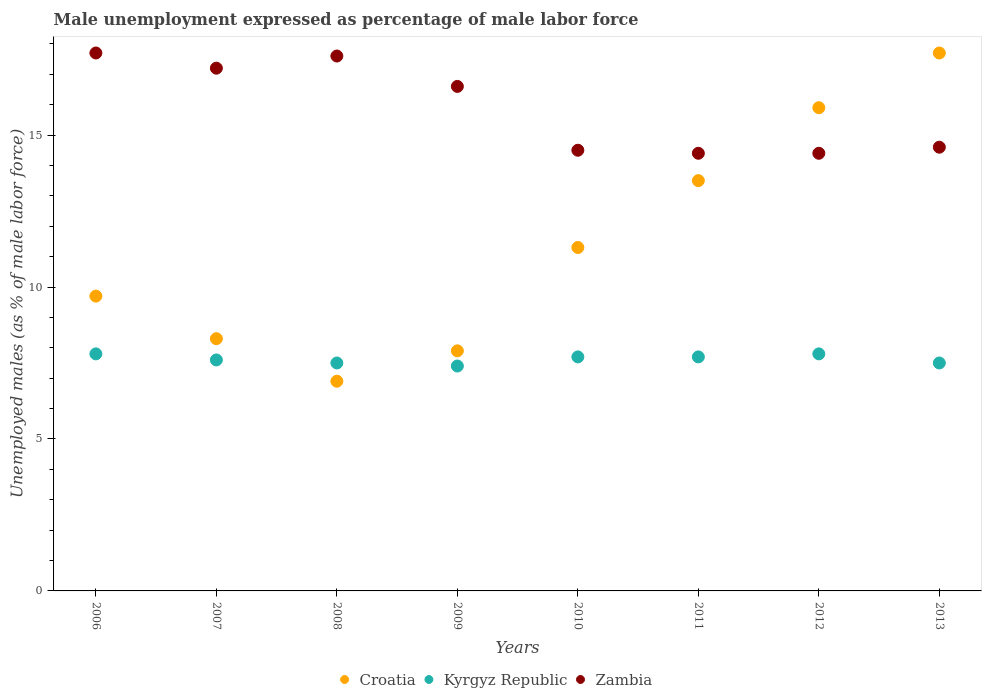Is the number of dotlines equal to the number of legend labels?
Your response must be concise. Yes. What is the unemployment in males in in Kyrgyz Republic in 2011?
Ensure brevity in your answer.  7.7. Across all years, what is the maximum unemployment in males in in Zambia?
Provide a short and direct response. 17.7. Across all years, what is the minimum unemployment in males in in Kyrgyz Republic?
Keep it short and to the point. 7.4. In which year was the unemployment in males in in Kyrgyz Republic minimum?
Offer a terse response. 2009. What is the difference between the unemployment in males in in Croatia in 2006 and that in 2013?
Give a very brief answer. -8. What is the difference between the unemployment in males in in Kyrgyz Republic in 2006 and the unemployment in males in in Zambia in 2010?
Provide a succinct answer. -6.7. What is the average unemployment in males in in Kyrgyz Republic per year?
Make the answer very short. 7.62. In the year 2008, what is the difference between the unemployment in males in in Kyrgyz Republic and unemployment in males in in Croatia?
Provide a short and direct response. 0.6. In how many years, is the unemployment in males in in Kyrgyz Republic greater than 17 %?
Your response must be concise. 0. What is the ratio of the unemployment in males in in Kyrgyz Republic in 2007 to that in 2010?
Provide a short and direct response. 0.99. What is the difference between the highest and the lowest unemployment in males in in Zambia?
Keep it short and to the point. 3.3. In how many years, is the unemployment in males in in Zambia greater than the average unemployment in males in in Zambia taken over all years?
Your response must be concise. 4. Is the unemployment in males in in Croatia strictly greater than the unemployment in males in in Kyrgyz Republic over the years?
Give a very brief answer. No. Is the unemployment in males in in Zambia strictly less than the unemployment in males in in Kyrgyz Republic over the years?
Keep it short and to the point. No. How many years are there in the graph?
Your response must be concise. 8. What is the difference between two consecutive major ticks on the Y-axis?
Make the answer very short. 5. Are the values on the major ticks of Y-axis written in scientific E-notation?
Give a very brief answer. No. Does the graph contain any zero values?
Ensure brevity in your answer.  No. Does the graph contain grids?
Make the answer very short. No. How are the legend labels stacked?
Your answer should be very brief. Horizontal. What is the title of the graph?
Provide a succinct answer. Male unemployment expressed as percentage of male labor force. Does "Dominican Republic" appear as one of the legend labels in the graph?
Your answer should be compact. No. What is the label or title of the Y-axis?
Offer a terse response. Unemployed males (as % of male labor force). What is the Unemployed males (as % of male labor force) in Croatia in 2006?
Make the answer very short. 9.7. What is the Unemployed males (as % of male labor force) of Kyrgyz Republic in 2006?
Your answer should be very brief. 7.8. What is the Unemployed males (as % of male labor force) of Zambia in 2006?
Provide a short and direct response. 17.7. What is the Unemployed males (as % of male labor force) in Croatia in 2007?
Offer a very short reply. 8.3. What is the Unemployed males (as % of male labor force) in Kyrgyz Republic in 2007?
Keep it short and to the point. 7.6. What is the Unemployed males (as % of male labor force) of Zambia in 2007?
Your answer should be very brief. 17.2. What is the Unemployed males (as % of male labor force) of Croatia in 2008?
Offer a very short reply. 6.9. What is the Unemployed males (as % of male labor force) in Kyrgyz Republic in 2008?
Your response must be concise. 7.5. What is the Unemployed males (as % of male labor force) in Zambia in 2008?
Make the answer very short. 17.6. What is the Unemployed males (as % of male labor force) in Croatia in 2009?
Offer a terse response. 7.9. What is the Unemployed males (as % of male labor force) of Kyrgyz Republic in 2009?
Give a very brief answer. 7.4. What is the Unemployed males (as % of male labor force) in Zambia in 2009?
Make the answer very short. 16.6. What is the Unemployed males (as % of male labor force) in Croatia in 2010?
Ensure brevity in your answer.  11.3. What is the Unemployed males (as % of male labor force) of Kyrgyz Republic in 2010?
Provide a succinct answer. 7.7. What is the Unemployed males (as % of male labor force) of Kyrgyz Republic in 2011?
Provide a short and direct response. 7.7. What is the Unemployed males (as % of male labor force) in Zambia in 2011?
Your answer should be very brief. 14.4. What is the Unemployed males (as % of male labor force) in Croatia in 2012?
Offer a terse response. 15.9. What is the Unemployed males (as % of male labor force) of Kyrgyz Republic in 2012?
Offer a terse response. 7.8. What is the Unemployed males (as % of male labor force) of Zambia in 2012?
Make the answer very short. 14.4. What is the Unemployed males (as % of male labor force) of Croatia in 2013?
Provide a succinct answer. 17.7. What is the Unemployed males (as % of male labor force) in Zambia in 2013?
Your answer should be compact. 14.6. Across all years, what is the maximum Unemployed males (as % of male labor force) in Croatia?
Give a very brief answer. 17.7. Across all years, what is the maximum Unemployed males (as % of male labor force) of Kyrgyz Republic?
Make the answer very short. 7.8. Across all years, what is the maximum Unemployed males (as % of male labor force) of Zambia?
Offer a terse response. 17.7. Across all years, what is the minimum Unemployed males (as % of male labor force) in Croatia?
Keep it short and to the point. 6.9. Across all years, what is the minimum Unemployed males (as % of male labor force) in Kyrgyz Republic?
Provide a short and direct response. 7.4. Across all years, what is the minimum Unemployed males (as % of male labor force) in Zambia?
Ensure brevity in your answer.  14.4. What is the total Unemployed males (as % of male labor force) in Croatia in the graph?
Keep it short and to the point. 91.2. What is the total Unemployed males (as % of male labor force) of Kyrgyz Republic in the graph?
Offer a terse response. 61. What is the total Unemployed males (as % of male labor force) of Zambia in the graph?
Provide a succinct answer. 127. What is the difference between the Unemployed males (as % of male labor force) of Croatia in 2006 and that in 2007?
Make the answer very short. 1.4. What is the difference between the Unemployed males (as % of male labor force) of Croatia in 2006 and that in 2008?
Provide a succinct answer. 2.8. What is the difference between the Unemployed males (as % of male labor force) of Zambia in 2006 and that in 2008?
Ensure brevity in your answer.  0.1. What is the difference between the Unemployed males (as % of male labor force) in Croatia in 2006 and that in 2009?
Your answer should be compact. 1.8. What is the difference between the Unemployed males (as % of male labor force) in Croatia in 2006 and that in 2010?
Give a very brief answer. -1.6. What is the difference between the Unemployed males (as % of male labor force) of Zambia in 2006 and that in 2010?
Ensure brevity in your answer.  3.2. What is the difference between the Unemployed males (as % of male labor force) in Croatia in 2006 and that in 2011?
Make the answer very short. -3.8. What is the difference between the Unemployed males (as % of male labor force) of Zambia in 2006 and that in 2011?
Give a very brief answer. 3.3. What is the difference between the Unemployed males (as % of male labor force) in Kyrgyz Republic in 2006 and that in 2013?
Your answer should be very brief. 0.3. What is the difference between the Unemployed males (as % of male labor force) in Zambia in 2006 and that in 2013?
Ensure brevity in your answer.  3.1. What is the difference between the Unemployed males (as % of male labor force) of Kyrgyz Republic in 2007 and that in 2008?
Provide a succinct answer. 0.1. What is the difference between the Unemployed males (as % of male labor force) in Zambia in 2007 and that in 2008?
Give a very brief answer. -0.4. What is the difference between the Unemployed males (as % of male labor force) in Zambia in 2007 and that in 2010?
Your response must be concise. 2.7. What is the difference between the Unemployed males (as % of male labor force) of Croatia in 2007 and that in 2011?
Give a very brief answer. -5.2. What is the difference between the Unemployed males (as % of male labor force) in Kyrgyz Republic in 2007 and that in 2011?
Your response must be concise. -0.1. What is the difference between the Unemployed males (as % of male labor force) in Zambia in 2007 and that in 2011?
Provide a succinct answer. 2.8. What is the difference between the Unemployed males (as % of male labor force) of Kyrgyz Republic in 2007 and that in 2013?
Make the answer very short. 0.1. What is the difference between the Unemployed males (as % of male labor force) of Zambia in 2007 and that in 2013?
Provide a short and direct response. 2.6. What is the difference between the Unemployed males (as % of male labor force) in Kyrgyz Republic in 2008 and that in 2009?
Provide a succinct answer. 0.1. What is the difference between the Unemployed males (as % of male labor force) in Zambia in 2008 and that in 2009?
Your answer should be very brief. 1. What is the difference between the Unemployed males (as % of male labor force) in Kyrgyz Republic in 2008 and that in 2010?
Keep it short and to the point. -0.2. What is the difference between the Unemployed males (as % of male labor force) in Zambia in 2008 and that in 2010?
Ensure brevity in your answer.  3.1. What is the difference between the Unemployed males (as % of male labor force) of Kyrgyz Republic in 2008 and that in 2011?
Provide a short and direct response. -0.2. What is the difference between the Unemployed males (as % of male labor force) of Croatia in 2008 and that in 2012?
Your answer should be very brief. -9. What is the difference between the Unemployed males (as % of male labor force) of Croatia in 2008 and that in 2013?
Offer a very short reply. -10.8. What is the difference between the Unemployed males (as % of male labor force) in Croatia in 2009 and that in 2010?
Your answer should be very brief. -3.4. What is the difference between the Unemployed males (as % of male labor force) in Kyrgyz Republic in 2009 and that in 2011?
Provide a short and direct response. -0.3. What is the difference between the Unemployed males (as % of male labor force) in Croatia in 2009 and that in 2012?
Your answer should be very brief. -8. What is the difference between the Unemployed males (as % of male labor force) of Kyrgyz Republic in 2009 and that in 2012?
Ensure brevity in your answer.  -0.4. What is the difference between the Unemployed males (as % of male labor force) of Croatia in 2009 and that in 2013?
Offer a very short reply. -9.8. What is the difference between the Unemployed males (as % of male labor force) of Zambia in 2010 and that in 2011?
Ensure brevity in your answer.  0.1. What is the difference between the Unemployed males (as % of male labor force) of Kyrgyz Republic in 2010 and that in 2012?
Ensure brevity in your answer.  -0.1. What is the difference between the Unemployed males (as % of male labor force) in Zambia in 2010 and that in 2012?
Your answer should be compact. 0.1. What is the difference between the Unemployed males (as % of male labor force) in Zambia in 2010 and that in 2013?
Give a very brief answer. -0.1. What is the difference between the Unemployed males (as % of male labor force) of Croatia in 2011 and that in 2012?
Your response must be concise. -2.4. What is the difference between the Unemployed males (as % of male labor force) of Croatia in 2012 and that in 2013?
Make the answer very short. -1.8. What is the difference between the Unemployed males (as % of male labor force) of Zambia in 2012 and that in 2013?
Your response must be concise. -0.2. What is the difference between the Unemployed males (as % of male labor force) in Croatia in 2006 and the Unemployed males (as % of male labor force) in Zambia in 2008?
Offer a very short reply. -7.9. What is the difference between the Unemployed males (as % of male labor force) of Kyrgyz Republic in 2006 and the Unemployed males (as % of male labor force) of Zambia in 2008?
Make the answer very short. -9.8. What is the difference between the Unemployed males (as % of male labor force) in Croatia in 2006 and the Unemployed males (as % of male labor force) in Kyrgyz Republic in 2010?
Give a very brief answer. 2. What is the difference between the Unemployed males (as % of male labor force) of Kyrgyz Republic in 2006 and the Unemployed males (as % of male labor force) of Zambia in 2010?
Your response must be concise. -6.7. What is the difference between the Unemployed males (as % of male labor force) in Croatia in 2006 and the Unemployed males (as % of male labor force) in Kyrgyz Republic in 2011?
Give a very brief answer. 2. What is the difference between the Unemployed males (as % of male labor force) in Kyrgyz Republic in 2006 and the Unemployed males (as % of male labor force) in Zambia in 2011?
Offer a terse response. -6.6. What is the difference between the Unemployed males (as % of male labor force) in Kyrgyz Republic in 2006 and the Unemployed males (as % of male labor force) in Zambia in 2012?
Provide a short and direct response. -6.6. What is the difference between the Unemployed males (as % of male labor force) of Croatia in 2006 and the Unemployed males (as % of male labor force) of Kyrgyz Republic in 2013?
Your answer should be very brief. 2.2. What is the difference between the Unemployed males (as % of male labor force) of Croatia in 2006 and the Unemployed males (as % of male labor force) of Zambia in 2013?
Keep it short and to the point. -4.9. What is the difference between the Unemployed males (as % of male labor force) in Kyrgyz Republic in 2006 and the Unemployed males (as % of male labor force) in Zambia in 2013?
Ensure brevity in your answer.  -6.8. What is the difference between the Unemployed males (as % of male labor force) of Croatia in 2007 and the Unemployed males (as % of male labor force) of Zambia in 2008?
Ensure brevity in your answer.  -9.3. What is the difference between the Unemployed males (as % of male labor force) in Kyrgyz Republic in 2007 and the Unemployed males (as % of male labor force) in Zambia in 2008?
Make the answer very short. -10. What is the difference between the Unemployed males (as % of male labor force) in Kyrgyz Republic in 2007 and the Unemployed males (as % of male labor force) in Zambia in 2009?
Make the answer very short. -9. What is the difference between the Unemployed males (as % of male labor force) in Kyrgyz Republic in 2007 and the Unemployed males (as % of male labor force) in Zambia in 2011?
Give a very brief answer. -6.8. What is the difference between the Unemployed males (as % of male labor force) of Croatia in 2007 and the Unemployed males (as % of male labor force) of Kyrgyz Republic in 2012?
Your answer should be compact. 0.5. What is the difference between the Unemployed males (as % of male labor force) of Kyrgyz Republic in 2007 and the Unemployed males (as % of male labor force) of Zambia in 2012?
Provide a succinct answer. -6.8. What is the difference between the Unemployed males (as % of male labor force) of Croatia in 2007 and the Unemployed males (as % of male labor force) of Zambia in 2013?
Your answer should be very brief. -6.3. What is the difference between the Unemployed males (as % of male labor force) in Kyrgyz Republic in 2007 and the Unemployed males (as % of male labor force) in Zambia in 2013?
Offer a terse response. -7. What is the difference between the Unemployed males (as % of male labor force) in Croatia in 2008 and the Unemployed males (as % of male labor force) in Kyrgyz Republic in 2009?
Your answer should be compact. -0.5. What is the difference between the Unemployed males (as % of male labor force) in Kyrgyz Republic in 2008 and the Unemployed males (as % of male labor force) in Zambia in 2009?
Your response must be concise. -9.1. What is the difference between the Unemployed males (as % of male labor force) in Croatia in 2008 and the Unemployed males (as % of male labor force) in Kyrgyz Republic in 2010?
Your answer should be compact. -0.8. What is the difference between the Unemployed males (as % of male labor force) of Croatia in 2008 and the Unemployed males (as % of male labor force) of Kyrgyz Republic in 2011?
Ensure brevity in your answer.  -0.8. What is the difference between the Unemployed males (as % of male labor force) in Croatia in 2008 and the Unemployed males (as % of male labor force) in Zambia in 2011?
Your answer should be very brief. -7.5. What is the difference between the Unemployed males (as % of male labor force) of Kyrgyz Republic in 2008 and the Unemployed males (as % of male labor force) of Zambia in 2011?
Your response must be concise. -6.9. What is the difference between the Unemployed males (as % of male labor force) in Kyrgyz Republic in 2008 and the Unemployed males (as % of male labor force) in Zambia in 2012?
Your answer should be very brief. -6.9. What is the difference between the Unemployed males (as % of male labor force) in Kyrgyz Republic in 2008 and the Unemployed males (as % of male labor force) in Zambia in 2013?
Keep it short and to the point. -7.1. What is the difference between the Unemployed males (as % of male labor force) in Croatia in 2009 and the Unemployed males (as % of male labor force) in Zambia in 2012?
Provide a short and direct response. -6.5. What is the difference between the Unemployed males (as % of male labor force) in Kyrgyz Republic in 2009 and the Unemployed males (as % of male labor force) in Zambia in 2012?
Make the answer very short. -7. What is the difference between the Unemployed males (as % of male labor force) of Kyrgyz Republic in 2009 and the Unemployed males (as % of male labor force) of Zambia in 2013?
Offer a terse response. -7.2. What is the difference between the Unemployed males (as % of male labor force) of Croatia in 2010 and the Unemployed males (as % of male labor force) of Kyrgyz Republic in 2011?
Offer a terse response. 3.6. What is the difference between the Unemployed males (as % of male labor force) of Croatia in 2010 and the Unemployed males (as % of male labor force) of Zambia in 2011?
Give a very brief answer. -3.1. What is the difference between the Unemployed males (as % of male labor force) of Kyrgyz Republic in 2010 and the Unemployed males (as % of male labor force) of Zambia in 2011?
Keep it short and to the point. -6.7. What is the difference between the Unemployed males (as % of male labor force) of Croatia in 2010 and the Unemployed males (as % of male labor force) of Kyrgyz Republic in 2012?
Give a very brief answer. 3.5. What is the difference between the Unemployed males (as % of male labor force) of Croatia in 2010 and the Unemployed males (as % of male labor force) of Zambia in 2012?
Your answer should be compact. -3.1. What is the difference between the Unemployed males (as % of male labor force) in Kyrgyz Republic in 2010 and the Unemployed males (as % of male labor force) in Zambia in 2012?
Give a very brief answer. -6.7. What is the difference between the Unemployed males (as % of male labor force) of Croatia in 2010 and the Unemployed males (as % of male labor force) of Kyrgyz Republic in 2013?
Offer a very short reply. 3.8. What is the difference between the Unemployed males (as % of male labor force) in Croatia in 2010 and the Unemployed males (as % of male labor force) in Zambia in 2013?
Your answer should be compact. -3.3. What is the difference between the Unemployed males (as % of male labor force) in Kyrgyz Republic in 2010 and the Unemployed males (as % of male labor force) in Zambia in 2013?
Ensure brevity in your answer.  -6.9. What is the difference between the Unemployed males (as % of male labor force) of Croatia in 2011 and the Unemployed males (as % of male labor force) of Zambia in 2012?
Offer a very short reply. -0.9. What is the difference between the Unemployed males (as % of male labor force) in Croatia in 2011 and the Unemployed males (as % of male labor force) in Zambia in 2013?
Your answer should be very brief. -1.1. What is the difference between the Unemployed males (as % of male labor force) of Croatia in 2012 and the Unemployed males (as % of male labor force) of Zambia in 2013?
Your answer should be very brief. 1.3. What is the difference between the Unemployed males (as % of male labor force) in Kyrgyz Republic in 2012 and the Unemployed males (as % of male labor force) in Zambia in 2013?
Keep it short and to the point. -6.8. What is the average Unemployed males (as % of male labor force) of Croatia per year?
Give a very brief answer. 11.4. What is the average Unemployed males (as % of male labor force) in Kyrgyz Republic per year?
Make the answer very short. 7.62. What is the average Unemployed males (as % of male labor force) of Zambia per year?
Give a very brief answer. 15.88. In the year 2006, what is the difference between the Unemployed males (as % of male labor force) in Croatia and Unemployed males (as % of male labor force) in Kyrgyz Republic?
Ensure brevity in your answer.  1.9. In the year 2006, what is the difference between the Unemployed males (as % of male labor force) in Croatia and Unemployed males (as % of male labor force) in Zambia?
Make the answer very short. -8. In the year 2006, what is the difference between the Unemployed males (as % of male labor force) in Kyrgyz Republic and Unemployed males (as % of male labor force) in Zambia?
Keep it short and to the point. -9.9. In the year 2007, what is the difference between the Unemployed males (as % of male labor force) of Croatia and Unemployed males (as % of male labor force) of Kyrgyz Republic?
Provide a succinct answer. 0.7. In the year 2007, what is the difference between the Unemployed males (as % of male labor force) in Kyrgyz Republic and Unemployed males (as % of male labor force) in Zambia?
Provide a short and direct response. -9.6. In the year 2008, what is the difference between the Unemployed males (as % of male labor force) of Croatia and Unemployed males (as % of male labor force) of Kyrgyz Republic?
Provide a succinct answer. -0.6. In the year 2008, what is the difference between the Unemployed males (as % of male labor force) of Croatia and Unemployed males (as % of male labor force) of Zambia?
Keep it short and to the point. -10.7. In the year 2008, what is the difference between the Unemployed males (as % of male labor force) of Kyrgyz Republic and Unemployed males (as % of male labor force) of Zambia?
Offer a terse response. -10.1. In the year 2009, what is the difference between the Unemployed males (as % of male labor force) of Croatia and Unemployed males (as % of male labor force) of Kyrgyz Republic?
Your response must be concise. 0.5. In the year 2010, what is the difference between the Unemployed males (as % of male labor force) in Croatia and Unemployed males (as % of male labor force) in Kyrgyz Republic?
Offer a very short reply. 3.6. In the year 2010, what is the difference between the Unemployed males (as % of male labor force) of Croatia and Unemployed males (as % of male labor force) of Zambia?
Your response must be concise. -3.2. In the year 2011, what is the difference between the Unemployed males (as % of male labor force) in Croatia and Unemployed males (as % of male labor force) in Kyrgyz Republic?
Give a very brief answer. 5.8. In the year 2011, what is the difference between the Unemployed males (as % of male labor force) of Croatia and Unemployed males (as % of male labor force) of Zambia?
Offer a terse response. -0.9. In the year 2012, what is the difference between the Unemployed males (as % of male labor force) in Croatia and Unemployed males (as % of male labor force) in Zambia?
Make the answer very short. 1.5. In the year 2012, what is the difference between the Unemployed males (as % of male labor force) in Kyrgyz Republic and Unemployed males (as % of male labor force) in Zambia?
Offer a terse response. -6.6. In the year 2013, what is the difference between the Unemployed males (as % of male labor force) of Croatia and Unemployed males (as % of male labor force) of Kyrgyz Republic?
Offer a terse response. 10.2. In the year 2013, what is the difference between the Unemployed males (as % of male labor force) in Croatia and Unemployed males (as % of male labor force) in Zambia?
Offer a terse response. 3.1. What is the ratio of the Unemployed males (as % of male labor force) in Croatia in 2006 to that in 2007?
Your answer should be compact. 1.17. What is the ratio of the Unemployed males (as % of male labor force) in Kyrgyz Republic in 2006 to that in 2007?
Offer a terse response. 1.03. What is the ratio of the Unemployed males (as % of male labor force) of Zambia in 2006 to that in 2007?
Provide a short and direct response. 1.03. What is the ratio of the Unemployed males (as % of male labor force) of Croatia in 2006 to that in 2008?
Keep it short and to the point. 1.41. What is the ratio of the Unemployed males (as % of male labor force) in Croatia in 2006 to that in 2009?
Your response must be concise. 1.23. What is the ratio of the Unemployed males (as % of male labor force) of Kyrgyz Republic in 2006 to that in 2009?
Offer a terse response. 1.05. What is the ratio of the Unemployed males (as % of male labor force) in Zambia in 2006 to that in 2009?
Ensure brevity in your answer.  1.07. What is the ratio of the Unemployed males (as % of male labor force) in Croatia in 2006 to that in 2010?
Your response must be concise. 0.86. What is the ratio of the Unemployed males (as % of male labor force) of Kyrgyz Republic in 2006 to that in 2010?
Offer a very short reply. 1.01. What is the ratio of the Unemployed males (as % of male labor force) in Zambia in 2006 to that in 2010?
Ensure brevity in your answer.  1.22. What is the ratio of the Unemployed males (as % of male labor force) of Croatia in 2006 to that in 2011?
Ensure brevity in your answer.  0.72. What is the ratio of the Unemployed males (as % of male labor force) of Kyrgyz Republic in 2006 to that in 2011?
Your answer should be very brief. 1.01. What is the ratio of the Unemployed males (as % of male labor force) in Zambia in 2006 to that in 2011?
Provide a short and direct response. 1.23. What is the ratio of the Unemployed males (as % of male labor force) of Croatia in 2006 to that in 2012?
Your response must be concise. 0.61. What is the ratio of the Unemployed males (as % of male labor force) in Kyrgyz Republic in 2006 to that in 2012?
Your answer should be compact. 1. What is the ratio of the Unemployed males (as % of male labor force) in Zambia in 2006 to that in 2012?
Provide a succinct answer. 1.23. What is the ratio of the Unemployed males (as % of male labor force) in Croatia in 2006 to that in 2013?
Your answer should be very brief. 0.55. What is the ratio of the Unemployed males (as % of male labor force) of Kyrgyz Republic in 2006 to that in 2013?
Your answer should be very brief. 1.04. What is the ratio of the Unemployed males (as % of male labor force) of Zambia in 2006 to that in 2013?
Ensure brevity in your answer.  1.21. What is the ratio of the Unemployed males (as % of male labor force) in Croatia in 2007 to that in 2008?
Keep it short and to the point. 1.2. What is the ratio of the Unemployed males (as % of male labor force) of Kyrgyz Republic in 2007 to that in 2008?
Your answer should be compact. 1.01. What is the ratio of the Unemployed males (as % of male labor force) in Zambia in 2007 to that in 2008?
Your answer should be very brief. 0.98. What is the ratio of the Unemployed males (as % of male labor force) of Croatia in 2007 to that in 2009?
Give a very brief answer. 1.05. What is the ratio of the Unemployed males (as % of male labor force) of Kyrgyz Republic in 2007 to that in 2009?
Your response must be concise. 1.03. What is the ratio of the Unemployed males (as % of male labor force) of Zambia in 2007 to that in 2009?
Give a very brief answer. 1.04. What is the ratio of the Unemployed males (as % of male labor force) in Croatia in 2007 to that in 2010?
Your answer should be compact. 0.73. What is the ratio of the Unemployed males (as % of male labor force) in Zambia in 2007 to that in 2010?
Offer a terse response. 1.19. What is the ratio of the Unemployed males (as % of male labor force) of Croatia in 2007 to that in 2011?
Offer a terse response. 0.61. What is the ratio of the Unemployed males (as % of male labor force) in Kyrgyz Republic in 2007 to that in 2011?
Keep it short and to the point. 0.99. What is the ratio of the Unemployed males (as % of male labor force) of Zambia in 2007 to that in 2011?
Your answer should be compact. 1.19. What is the ratio of the Unemployed males (as % of male labor force) of Croatia in 2007 to that in 2012?
Provide a short and direct response. 0.52. What is the ratio of the Unemployed males (as % of male labor force) of Kyrgyz Republic in 2007 to that in 2012?
Make the answer very short. 0.97. What is the ratio of the Unemployed males (as % of male labor force) of Zambia in 2007 to that in 2012?
Your answer should be compact. 1.19. What is the ratio of the Unemployed males (as % of male labor force) in Croatia in 2007 to that in 2013?
Provide a short and direct response. 0.47. What is the ratio of the Unemployed males (as % of male labor force) of Kyrgyz Republic in 2007 to that in 2013?
Give a very brief answer. 1.01. What is the ratio of the Unemployed males (as % of male labor force) of Zambia in 2007 to that in 2013?
Provide a succinct answer. 1.18. What is the ratio of the Unemployed males (as % of male labor force) in Croatia in 2008 to that in 2009?
Make the answer very short. 0.87. What is the ratio of the Unemployed males (as % of male labor force) in Kyrgyz Republic in 2008 to that in 2009?
Provide a succinct answer. 1.01. What is the ratio of the Unemployed males (as % of male labor force) in Zambia in 2008 to that in 2009?
Give a very brief answer. 1.06. What is the ratio of the Unemployed males (as % of male labor force) in Croatia in 2008 to that in 2010?
Keep it short and to the point. 0.61. What is the ratio of the Unemployed males (as % of male labor force) in Kyrgyz Republic in 2008 to that in 2010?
Ensure brevity in your answer.  0.97. What is the ratio of the Unemployed males (as % of male labor force) of Zambia in 2008 to that in 2010?
Offer a terse response. 1.21. What is the ratio of the Unemployed males (as % of male labor force) of Croatia in 2008 to that in 2011?
Make the answer very short. 0.51. What is the ratio of the Unemployed males (as % of male labor force) in Zambia in 2008 to that in 2011?
Provide a short and direct response. 1.22. What is the ratio of the Unemployed males (as % of male labor force) of Croatia in 2008 to that in 2012?
Offer a very short reply. 0.43. What is the ratio of the Unemployed males (as % of male labor force) of Kyrgyz Republic in 2008 to that in 2012?
Make the answer very short. 0.96. What is the ratio of the Unemployed males (as % of male labor force) in Zambia in 2008 to that in 2012?
Ensure brevity in your answer.  1.22. What is the ratio of the Unemployed males (as % of male labor force) of Croatia in 2008 to that in 2013?
Your answer should be compact. 0.39. What is the ratio of the Unemployed males (as % of male labor force) in Kyrgyz Republic in 2008 to that in 2013?
Your answer should be compact. 1. What is the ratio of the Unemployed males (as % of male labor force) in Zambia in 2008 to that in 2013?
Provide a short and direct response. 1.21. What is the ratio of the Unemployed males (as % of male labor force) of Croatia in 2009 to that in 2010?
Keep it short and to the point. 0.7. What is the ratio of the Unemployed males (as % of male labor force) of Zambia in 2009 to that in 2010?
Your answer should be very brief. 1.14. What is the ratio of the Unemployed males (as % of male labor force) in Croatia in 2009 to that in 2011?
Keep it short and to the point. 0.59. What is the ratio of the Unemployed males (as % of male labor force) of Zambia in 2009 to that in 2011?
Your answer should be very brief. 1.15. What is the ratio of the Unemployed males (as % of male labor force) in Croatia in 2009 to that in 2012?
Keep it short and to the point. 0.5. What is the ratio of the Unemployed males (as % of male labor force) of Kyrgyz Republic in 2009 to that in 2012?
Offer a terse response. 0.95. What is the ratio of the Unemployed males (as % of male labor force) in Zambia in 2009 to that in 2012?
Offer a very short reply. 1.15. What is the ratio of the Unemployed males (as % of male labor force) in Croatia in 2009 to that in 2013?
Provide a succinct answer. 0.45. What is the ratio of the Unemployed males (as % of male labor force) in Kyrgyz Republic in 2009 to that in 2013?
Your answer should be compact. 0.99. What is the ratio of the Unemployed males (as % of male labor force) of Zambia in 2009 to that in 2013?
Ensure brevity in your answer.  1.14. What is the ratio of the Unemployed males (as % of male labor force) in Croatia in 2010 to that in 2011?
Ensure brevity in your answer.  0.84. What is the ratio of the Unemployed males (as % of male labor force) in Kyrgyz Republic in 2010 to that in 2011?
Ensure brevity in your answer.  1. What is the ratio of the Unemployed males (as % of male labor force) of Croatia in 2010 to that in 2012?
Your answer should be very brief. 0.71. What is the ratio of the Unemployed males (as % of male labor force) in Kyrgyz Republic in 2010 to that in 2012?
Offer a very short reply. 0.99. What is the ratio of the Unemployed males (as % of male labor force) of Croatia in 2010 to that in 2013?
Ensure brevity in your answer.  0.64. What is the ratio of the Unemployed males (as % of male labor force) of Kyrgyz Republic in 2010 to that in 2013?
Your answer should be compact. 1.03. What is the ratio of the Unemployed males (as % of male labor force) of Croatia in 2011 to that in 2012?
Your answer should be very brief. 0.85. What is the ratio of the Unemployed males (as % of male labor force) of Kyrgyz Republic in 2011 to that in 2012?
Offer a very short reply. 0.99. What is the ratio of the Unemployed males (as % of male labor force) in Zambia in 2011 to that in 2012?
Your answer should be very brief. 1. What is the ratio of the Unemployed males (as % of male labor force) in Croatia in 2011 to that in 2013?
Your answer should be very brief. 0.76. What is the ratio of the Unemployed males (as % of male labor force) in Kyrgyz Republic in 2011 to that in 2013?
Offer a very short reply. 1.03. What is the ratio of the Unemployed males (as % of male labor force) of Zambia in 2011 to that in 2013?
Keep it short and to the point. 0.99. What is the ratio of the Unemployed males (as % of male labor force) in Croatia in 2012 to that in 2013?
Your response must be concise. 0.9. What is the ratio of the Unemployed males (as % of male labor force) of Zambia in 2012 to that in 2013?
Offer a very short reply. 0.99. What is the difference between the highest and the second highest Unemployed males (as % of male labor force) of Croatia?
Make the answer very short. 1.8. What is the difference between the highest and the second highest Unemployed males (as % of male labor force) in Kyrgyz Republic?
Keep it short and to the point. 0. What is the difference between the highest and the second highest Unemployed males (as % of male labor force) in Zambia?
Provide a short and direct response. 0.1. What is the difference between the highest and the lowest Unemployed males (as % of male labor force) of Croatia?
Your answer should be compact. 10.8. What is the difference between the highest and the lowest Unemployed males (as % of male labor force) of Kyrgyz Republic?
Keep it short and to the point. 0.4. What is the difference between the highest and the lowest Unemployed males (as % of male labor force) in Zambia?
Provide a short and direct response. 3.3. 